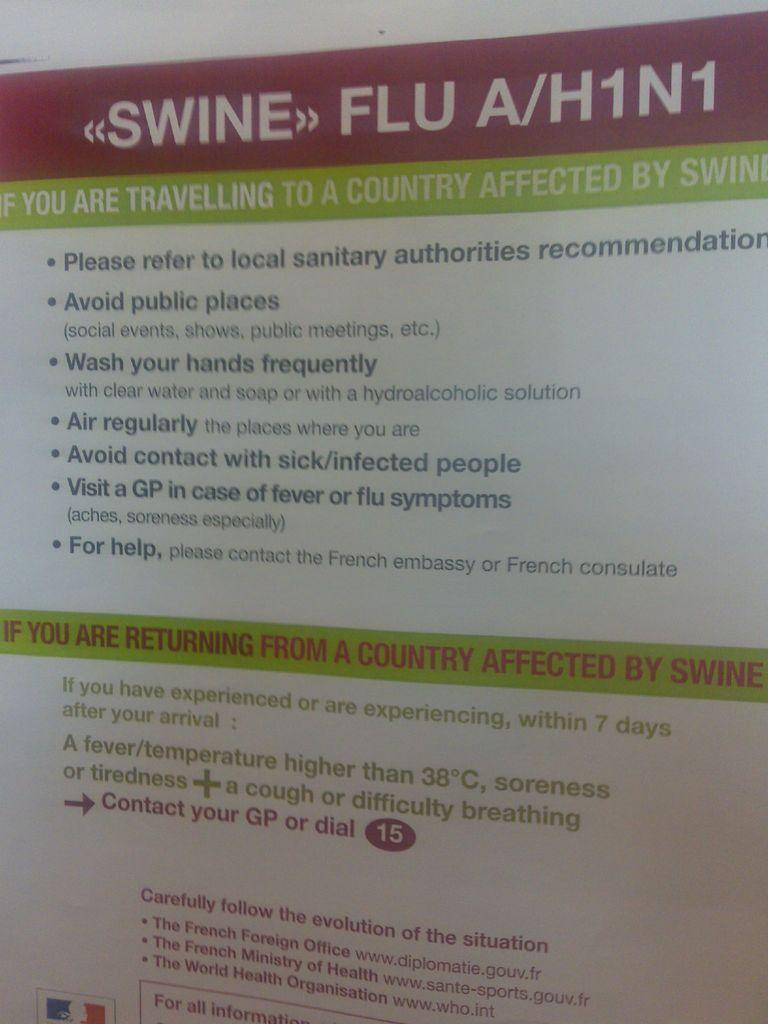<image>
Provide a brief description of the given image. a paper that has the word flu on it 